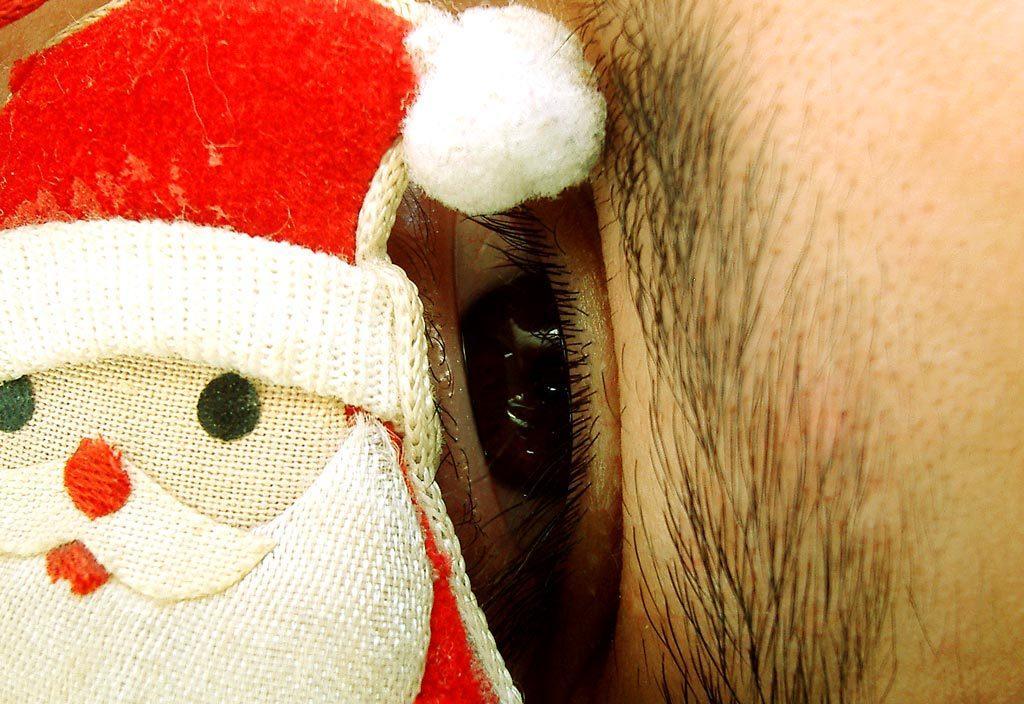How would you summarize this image in a sentence or two? In this image we can see a doll and in the background there is a person's eye. 